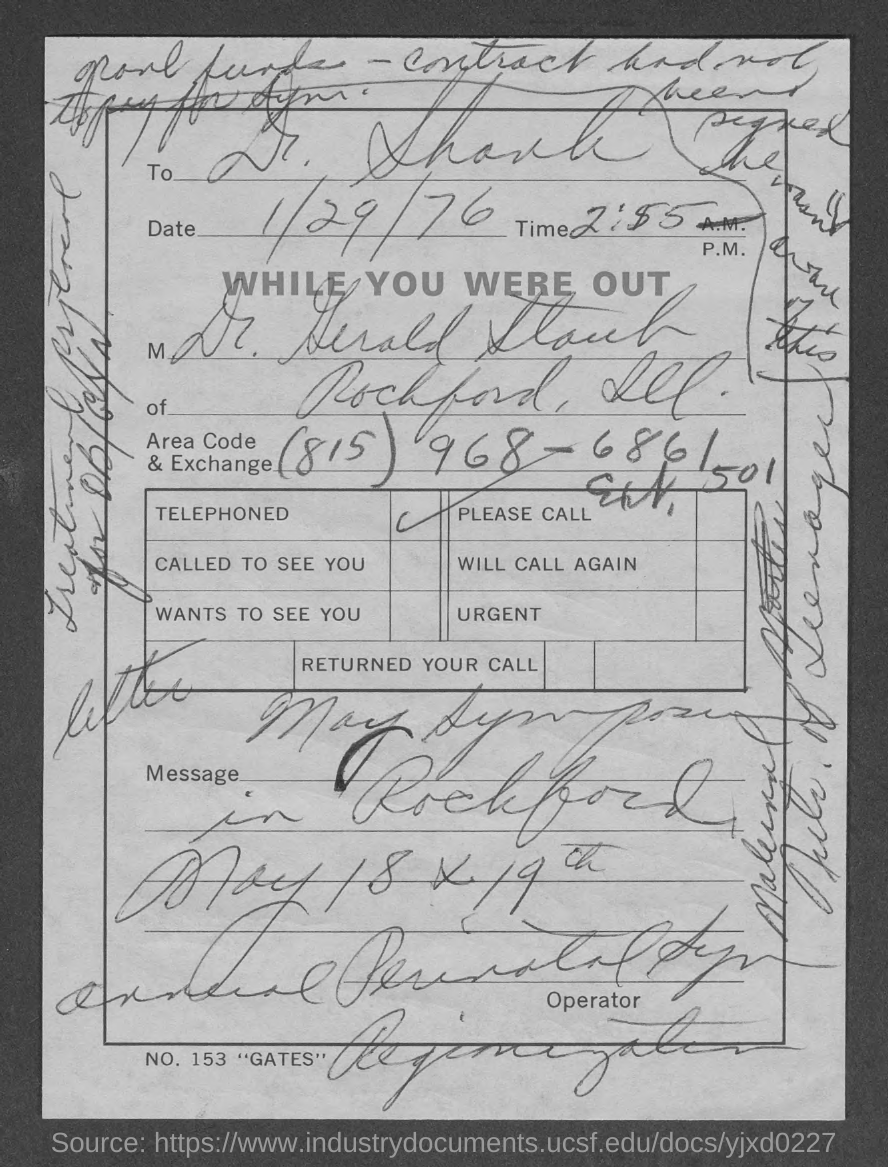Specify some key components in this picture. The date in the document is 1/29/76. The area code is (815). 